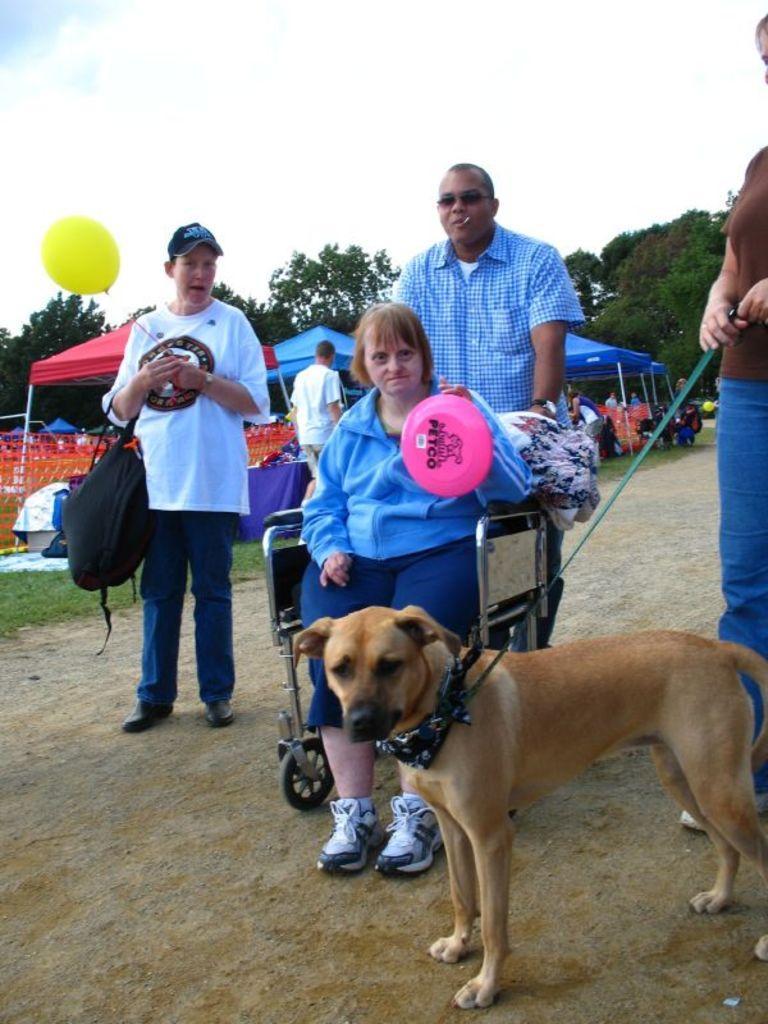Please provide a concise description of this image. In this image there are group of persons at the middle of the image there is a woman wearing blue color dress sitting on the wheel chair at the bottom of the image there is a dog which has a leash and at the left side of the image there is a person carrying backpack and yellow color balloon. 